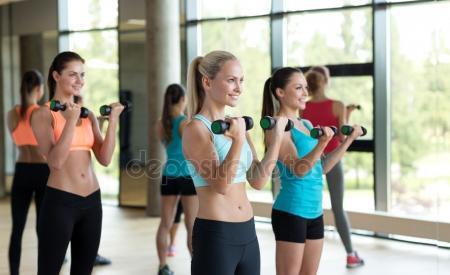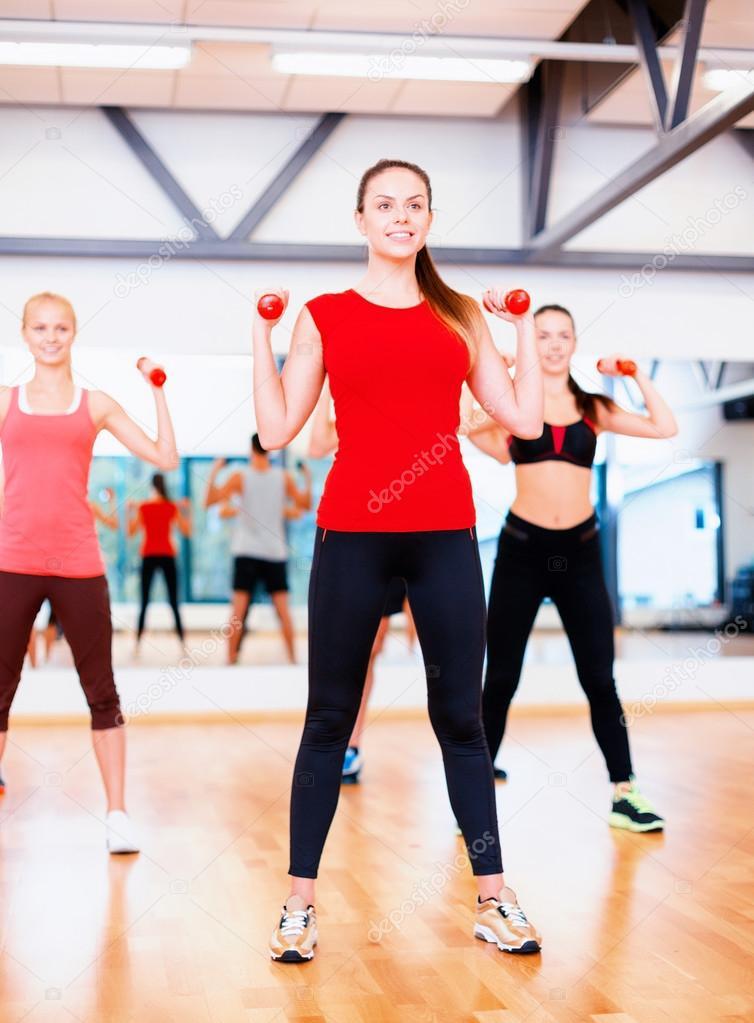The first image is the image on the left, the second image is the image on the right. For the images displayed, is the sentence "One image shows a workout with feet flat on the floor and hands holding dumbbells in front of the body, and the other image shows a similar workout with hands holding dumbbells out to the side." factually correct? Answer yes or no. Yes. The first image is the image on the left, the second image is the image on the right. Examine the images to the left and right. Is the description "At least five women are stepping on a workout step with one foot." accurate? Answer yes or no. No. 